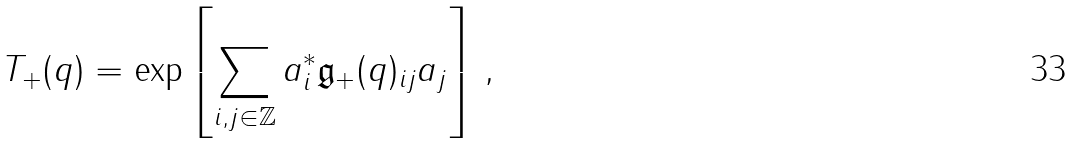<formula> <loc_0><loc_0><loc_500><loc_500>T _ { + } ( q ) = \exp \left [ \sum _ { i , j \in \mathbb { Z } } a ^ { \ast } _ { i } \mathfrak { g } _ { + } ( q ) _ { i j } a _ { j } \right ] \, ,</formula> 